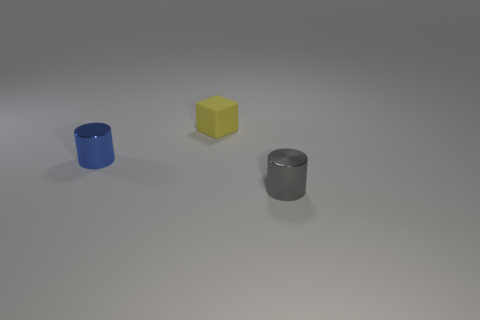Subtract all gray cylinders. How many cylinders are left? 1 Add 2 gray metallic cylinders. How many objects exist? 5 Subtract all cylinders. How many objects are left? 1 Add 1 yellow blocks. How many yellow blocks are left? 2 Add 3 small green shiny objects. How many small green shiny objects exist? 3 Subtract 0 red cylinders. How many objects are left? 3 Subtract all yellow cylinders. Subtract all green balls. How many cylinders are left? 2 Subtract all tiny yellow blocks. Subtract all blue metal things. How many objects are left? 1 